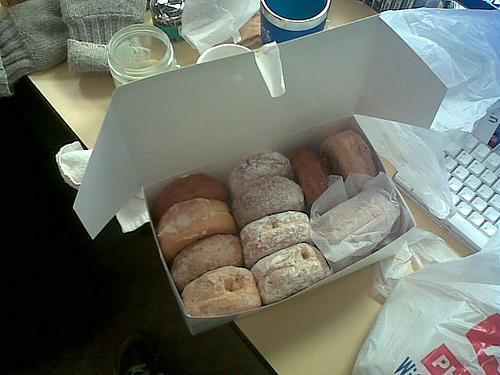How many donuts are there?
Give a very brief answer. 11. How many cups are visible?
Give a very brief answer. 2. 